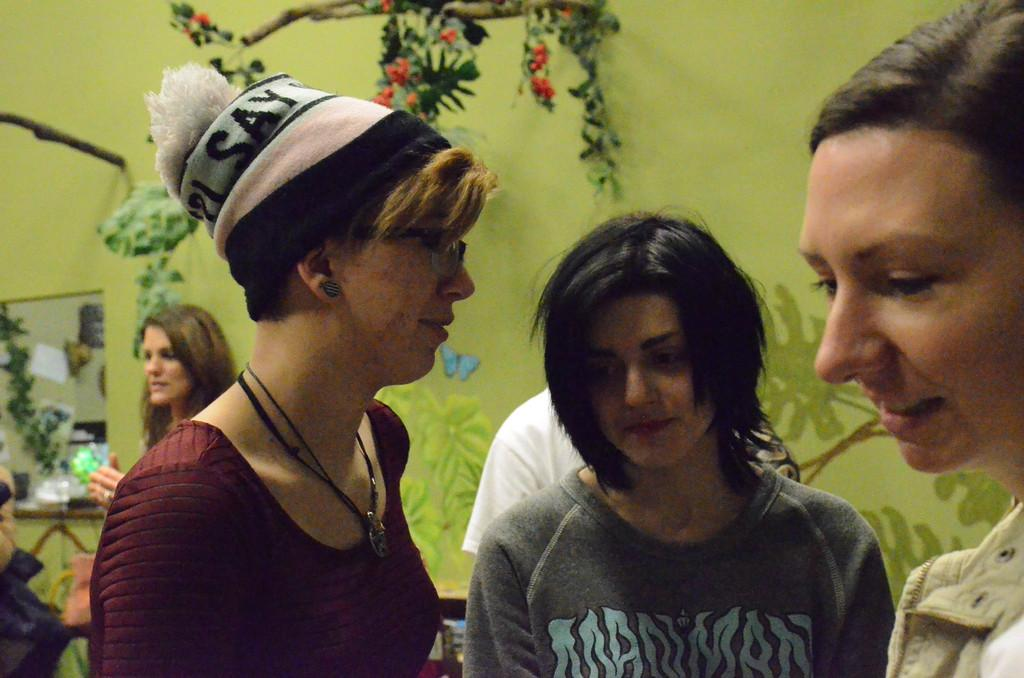Who or what can be seen in the image? There are people in the image. What is on the wall in the image? There is a painting and a mirror on the wall. What type of vegetation is present in the image? There are leaves and flowers in the image. What brand of toothpaste is being advertised in the image? There is no toothpaste or advertisement present in the image. How much rice is visible in the image? There is no rice present in the image. 